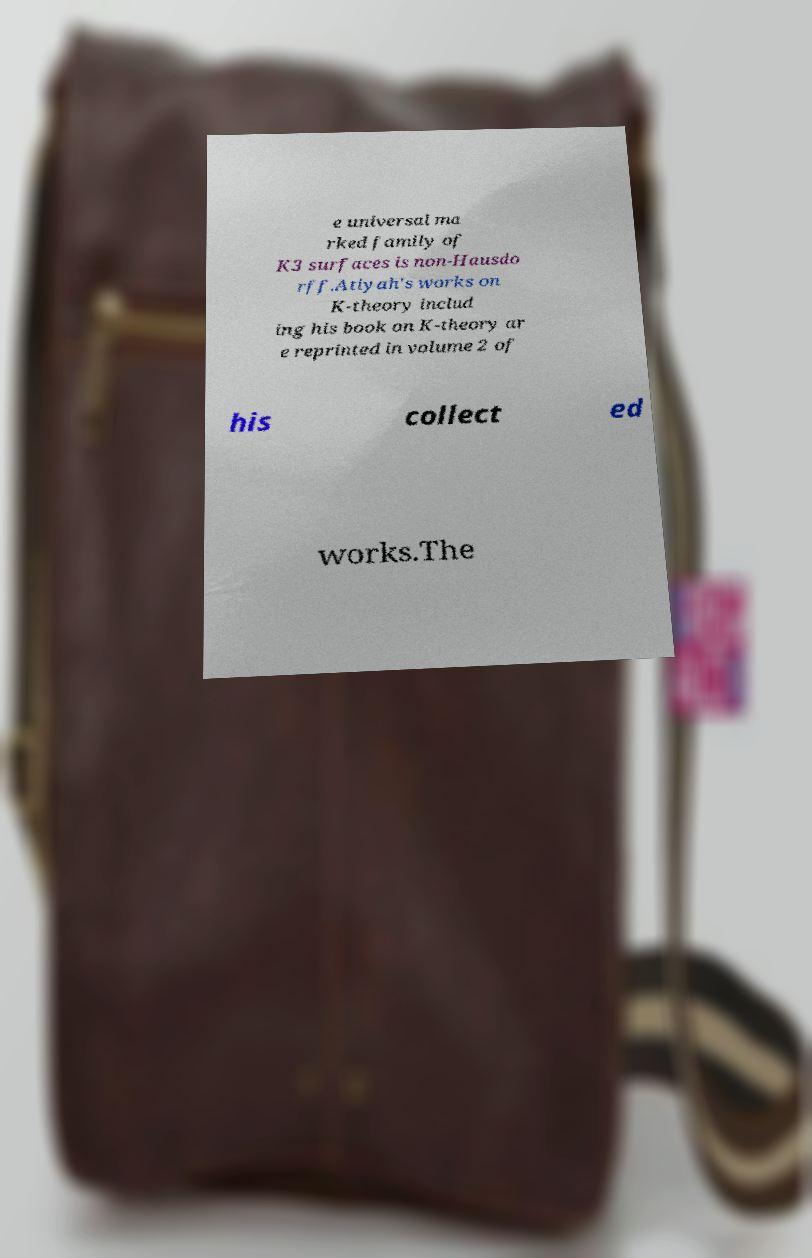Please read and relay the text visible in this image. What does it say? e universal ma rked family of K3 surfaces is non-Hausdo rff.Atiyah's works on K-theory includ ing his book on K-theory ar e reprinted in volume 2 of his collect ed works.The 